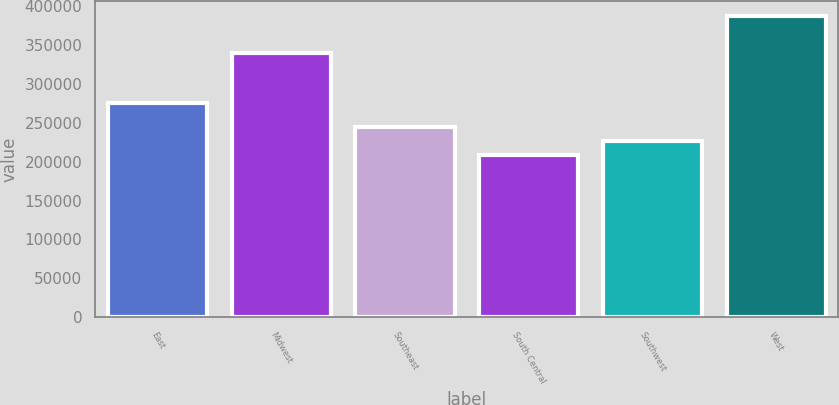Convert chart to OTSL. <chart><loc_0><loc_0><loc_500><loc_500><bar_chart><fcel>East<fcel>Midwest<fcel>Southeast<fcel>South Central<fcel>Southwest<fcel>West<nl><fcel>275800<fcel>340000<fcel>244280<fcel>208500<fcel>226390<fcel>387400<nl></chart> 